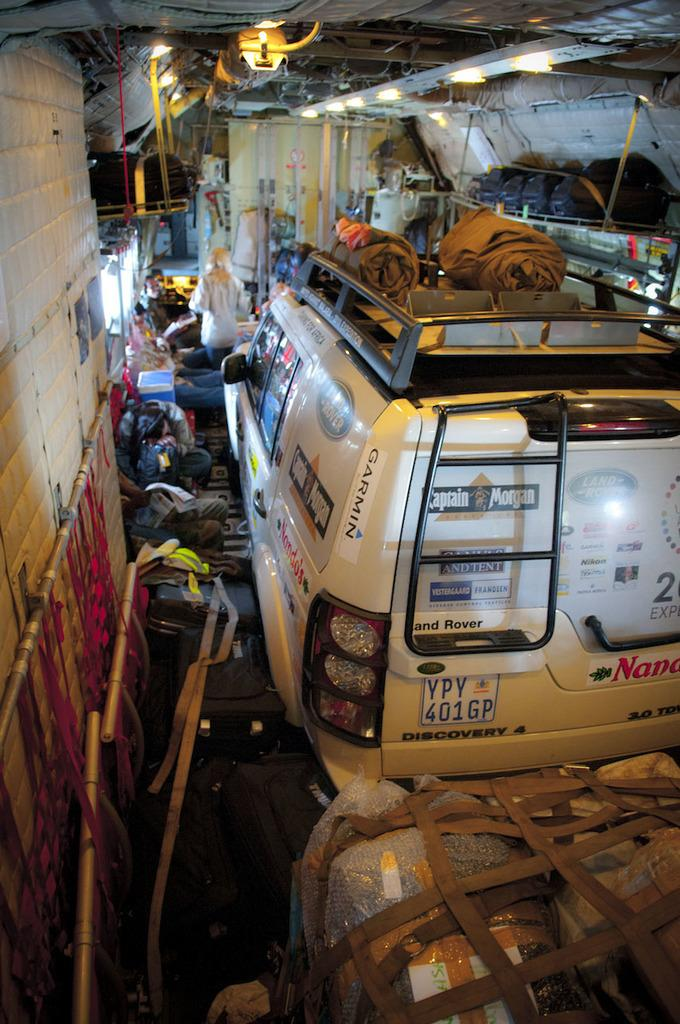Where is the location of the image? The image is in a tunnel. What can be seen in the tunnel? There is a car parked in the tunnel and a person standing in the tunnel. Are there any other objects present in the tunnel? Yes, there are other objects present in the tunnel. What type of stocking is being used in the image? There is no mention of stocking in the image. 